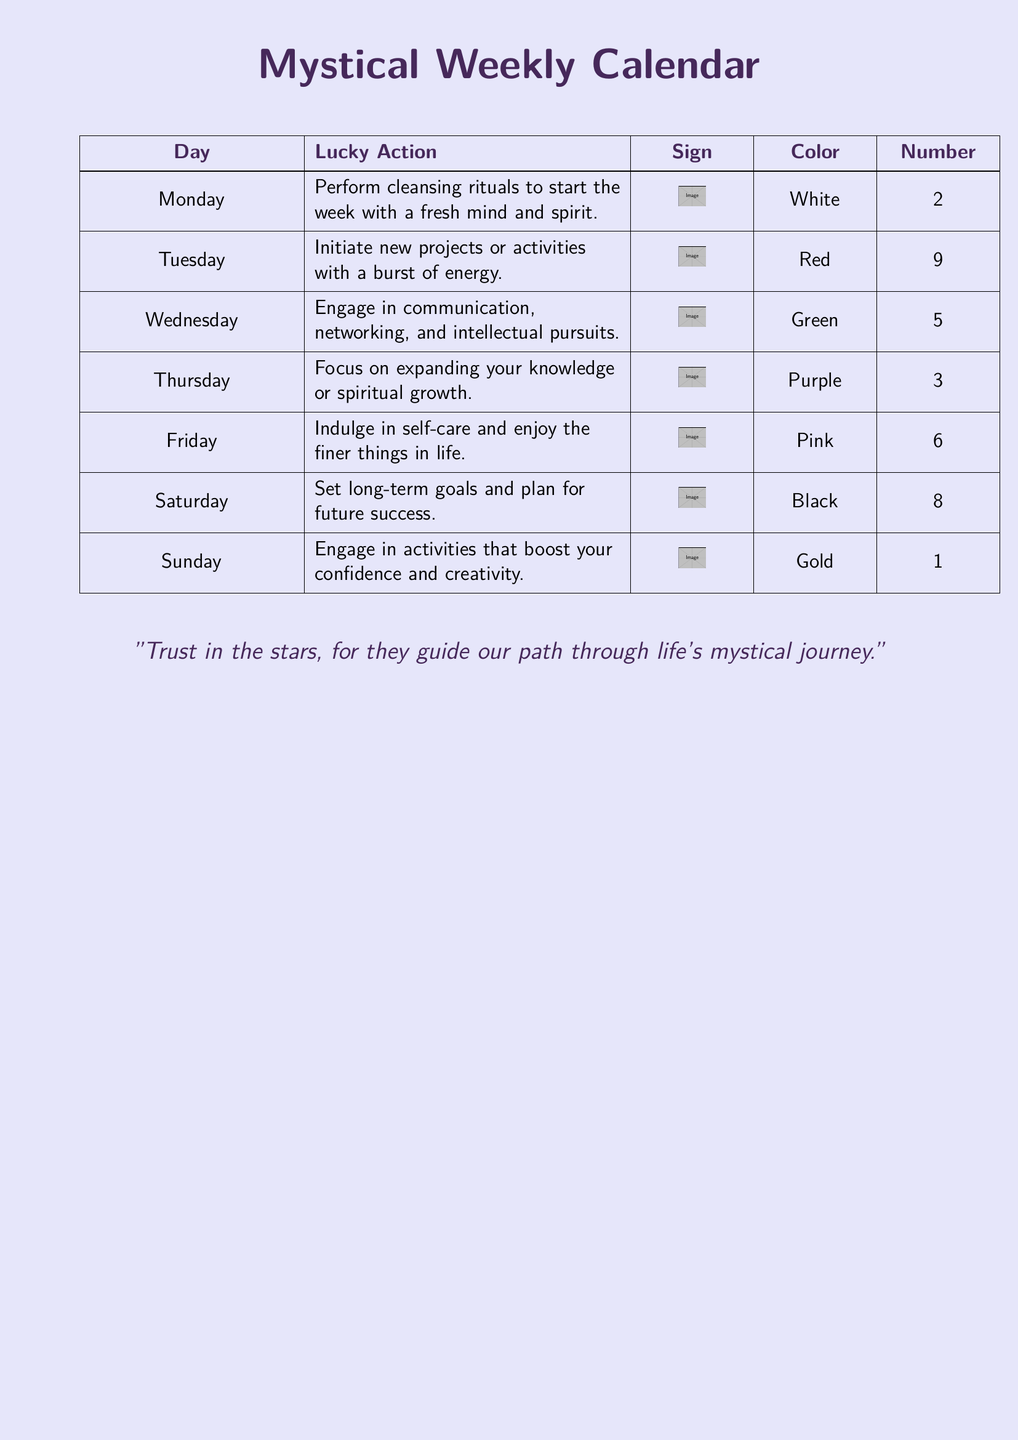What is the lucky action for Monday? The lucky action for Monday is stated in the calendar as performing cleansing rituals to start the week with a fresh mind and spirit.
Answer: Perform cleansing rituals What color is associated with Tuesday? The calendar specifies that the color associated with Tuesday is red.
Answer: Red Which day advises self-care? The calendar notes that Friday is the day to indulge in self-care and enjoy the finer things in life.
Answer: Friday What is the sign for Sunday? Based on the document, the sign for Sunday is represented in the calendar, which is not clearly defined in text.
Answer: Not specified What number is lucky on Thursday? The document lists the lucky number associated with Thursday as 3.
Answer: 3 On which day should long-term goals be set? The document indicates that Saturday is the day designated for setting long-term goals and planning for future success.
Answer: Saturday Which action is suggested for Wednesday? The calendar suggests engaging in communication, networking, and intellectual pursuits for Wednesday.
Answer: Engage in communication What is the overall theme suggested by the quote? The quote in the calendar emphasizes trusting the stars for guidance in life’s journey.
Answer: Trust in the stars What is the lucky color for Saturday? The calendar specifies that black is the lucky color for Saturday.
Answer: Black 